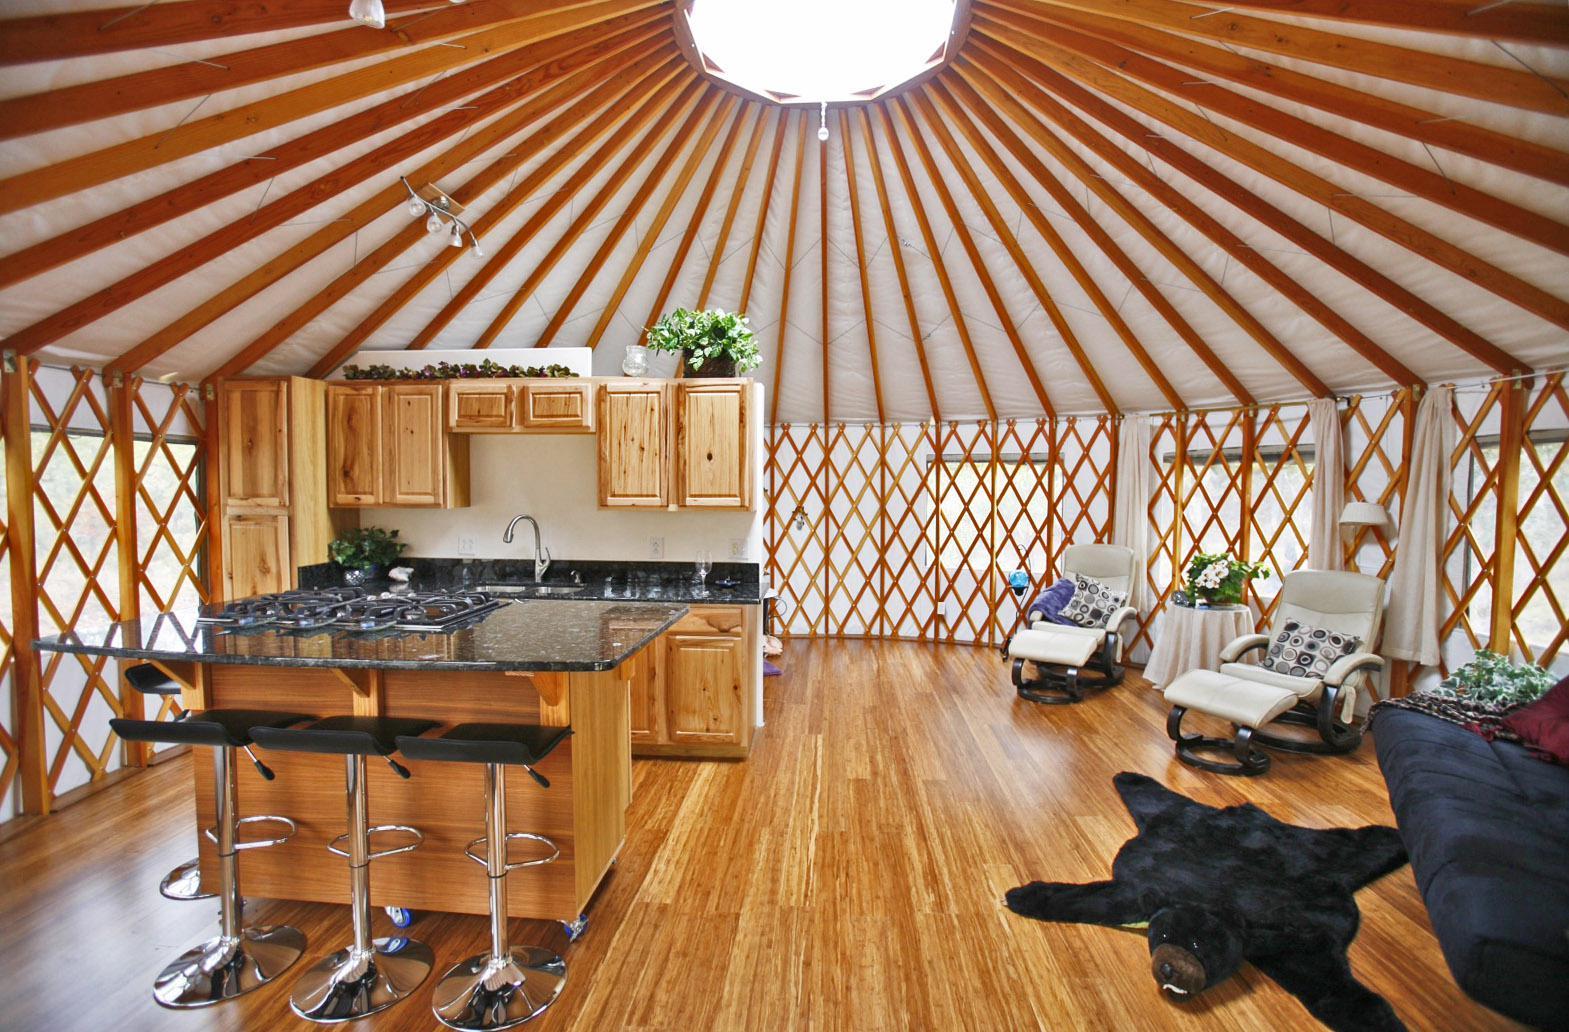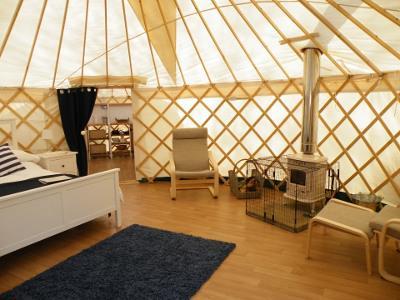The first image is the image on the left, the second image is the image on the right. Evaluate the accuracy of this statement regarding the images: "There is one striped pillow in the image on the right.". Is it true? Answer yes or no. Yes. 